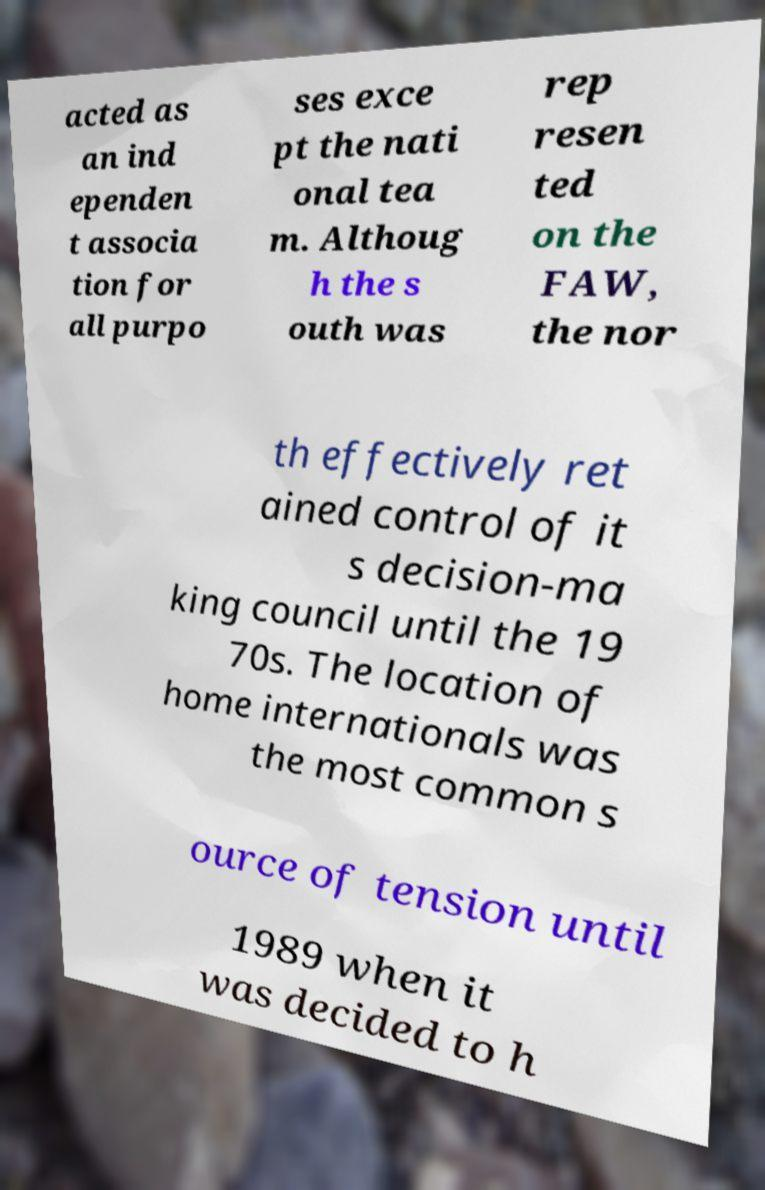Could you extract and type out the text from this image? acted as an ind ependen t associa tion for all purpo ses exce pt the nati onal tea m. Althoug h the s outh was rep resen ted on the FAW, the nor th effectively ret ained control of it s decision-ma king council until the 19 70s. The location of home internationals was the most common s ource of tension until 1989 when it was decided to h 